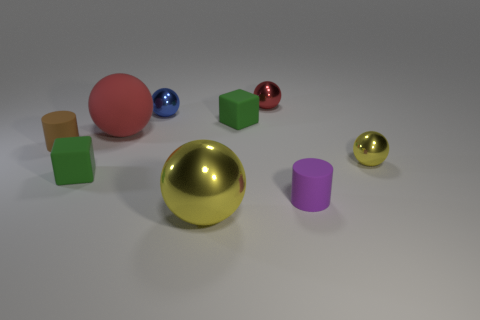There is another matte cylinder that is the same size as the brown rubber cylinder; what color is it?
Your answer should be compact. Purple. What number of small objects are rubber things or yellow cylinders?
Make the answer very short. 4. Are there an equal number of yellow balls in front of the tiny yellow metallic object and big metallic things that are behind the brown rubber thing?
Keep it short and to the point. No. What number of blue metallic objects have the same size as the brown thing?
Your answer should be compact. 1. How many gray things are either big balls or objects?
Ensure brevity in your answer.  0. Are there the same number of large matte things to the right of the small blue thing and small green shiny objects?
Ensure brevity in your answer.  Yes. There is a rubber cylinder that is left of the blue ball; how big is it?
Provide a succinct answer. Small. What number of large yellow shiny things are the same shape as the large red matte object?
Keep it short and to the point. 1. What is the small object that is both behind the large red thing and in front of the small blue metal sphere made of?
Keep it short and to the point. Rubber. Do the small blue object and the purple cylinder have the same material?
Ensure brevity in your answer.  No. 